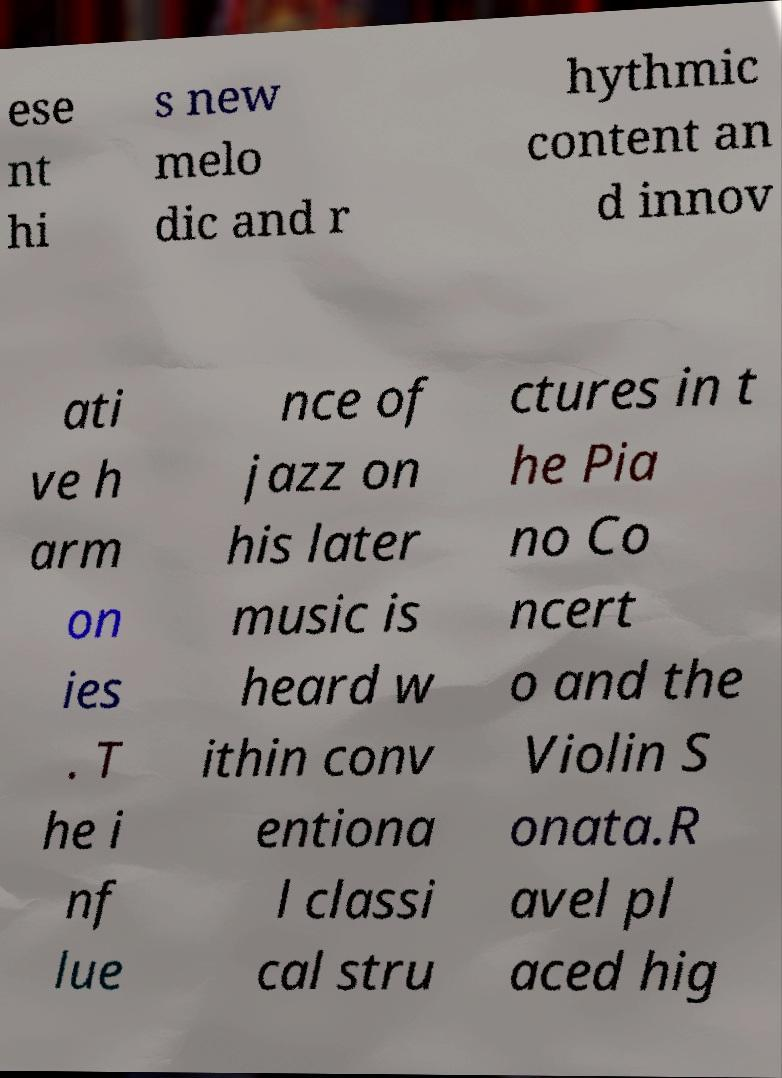Could you assist in decoding the text presented in this image and type it out clearly? ese nt hi s new melo dic and r hythmic content an d innov ati ve h arm on ies . T he i nf lue nce of jazz on his later music is heard w ithin conv entiona l classi cal stru ctures in t he Pia no Co ncert o and the Violin S onata.R avel pl aced hig 